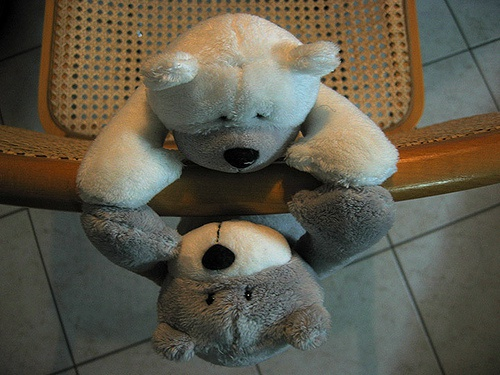Describe the objects in this image and their specific colors. I can see teddy bear in black, darkgray, gray, and tan tones, teddy bear in black, gray, and darkgray tones, and chair in black, olive, and gray tones in this image. 